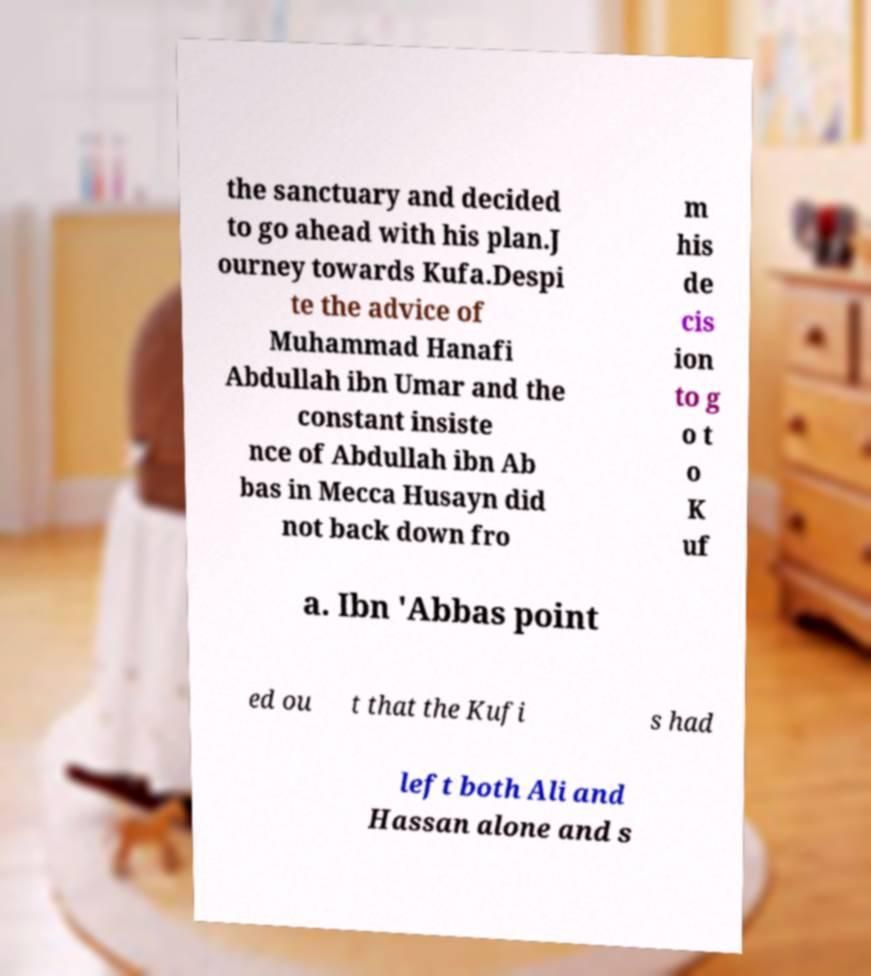I need the written content from this picture converted into text. Can you do that? the sanctuary and decided to go ahead with his plan.J ourney towards Kufa.Despi te the advice of Muhammad Hanafi Abdullah ibn Umar and the constant insiste nce of Abdullah ibn Ab bas in Mecca Husayn did not back down fro m his de cis ion to g o t o K uf a. Ibn 'Abbas point ed ou t that the Kufi s had left both Ali and Hassan alone and s 